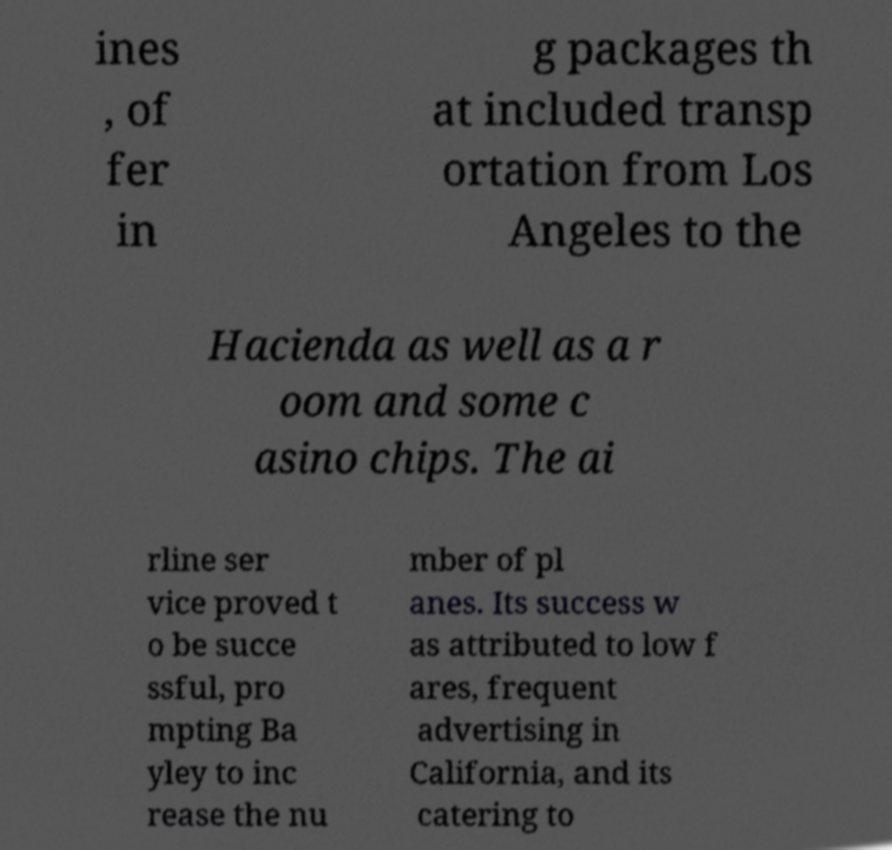Could you assist in decoding the text presented in this image and type it out clearly? ines , of fer in g packages th at included transp ortation from Los Angeles to the Hacienda as well as a r oom and some c asino chips. The ai rline ser vice proved t o be succe ssful, pro mpting Ba yley to inc rease the nu mber of pl anes. Its success w as attributed to low f ares, frequent advertising in California, and its catering to 